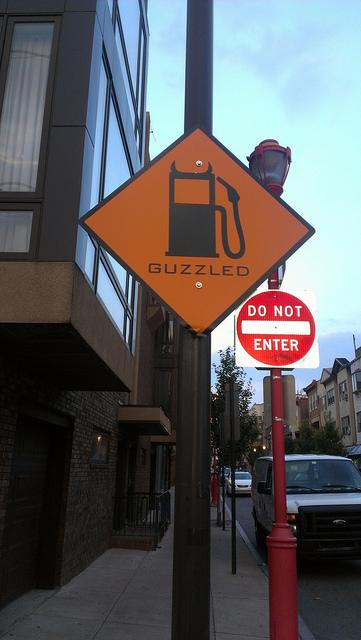Is there a car on the street?
Answer briefly. Yes. Is there a tree behind the sign?
Short answer required. Yes. What is red?
Write a very short answer. Sign. Can you enter here?
Answer briefly. No. Is it day or night outside?
Keep it brief. Day. What do the signs say?
Give a very brief answer. Guzzled. What does the sign say?
Keep it brief. Guzzled. What color is the building?
Answer briefly. Brown. What is pictured on the sign?
Quick response, please. Gas pump. What is pictured on the orange sign?
Be succinct. Gas pump. 